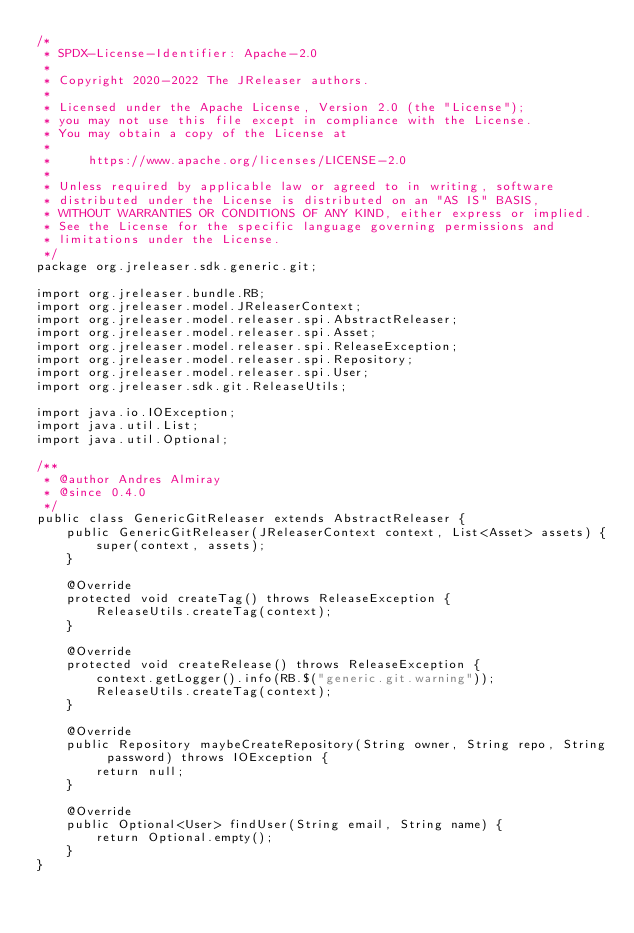<code> <loc_0><loc_0><loc_500><loc_500><_Java_>/*
 * SPDX-License-Identifier: Apache-2.0
 *
 * Copyright 2020-2022 The JReleaser authors.
 *
 * Licensed under the Apache License, Version 2.0 (the "License");
 * you may not use this file except in compliance with the License.
 * You may obtain a copy of the License at
 *
 *     https://www.apache.org/licenses/LICENSE-2.0
 *
 * Unless required by applicable law or agreed to in writing, software
 * distributed under the License is distributed on an "AS IS" BASIS,
 * WITHOUT WARRANTIES OR CONDITIONS OF ANY KIND, either express or implied.
 * See the License for the specific language governing permissions and
 * limitations under the License.
 */
package org.jreleaser.sdk.generic.git;

import org.jreleaser.bundle.RB;
import org.jreleaser.model.JReleaserContext;
import org.jreleaser.model.releaser.spi.AbstractReleaser;
import org.jreleaser.model.releaser.spi.Asset;
import org.jreleaser.model.releaser.spi.ReleaseException;
import org.jreleaser.model.releaser.spi.Repository;
import org.jreleaser.model.releaser.spi.User;
import org.jreleaser.sdk.git.ReleaseUtils;

import java.io.IOException;
import java.util.List;
import java.util.Optional;

/**
 * @author Andres Almiray
 * @since 0.4.0
 */
public class GenericGitReleaser extends AbstractReleaser {
    public GenericGitReleaser(JReleaserContext context, List<Asset> assets) {
        super(context, assets);
    }

    @Override
    protected void createTag() throws ReleaseException {
        ReleaseUtils.createTag(context);
    }

    @Override
    protected void createRelease() throws ReleaseException {
        context.getLogger().info(RB.$("generic.git.warning"));
        ReleaseUtils.createTag(context);
    }

    @Override
    public Repository maybeCreateRepository(String owner, String repo, String password) throws IOException {
        return null;
    }

    @Override
    public Optional<User> findUser(String email, String name) {
        return Optional.empty();
    }
}
</code> 